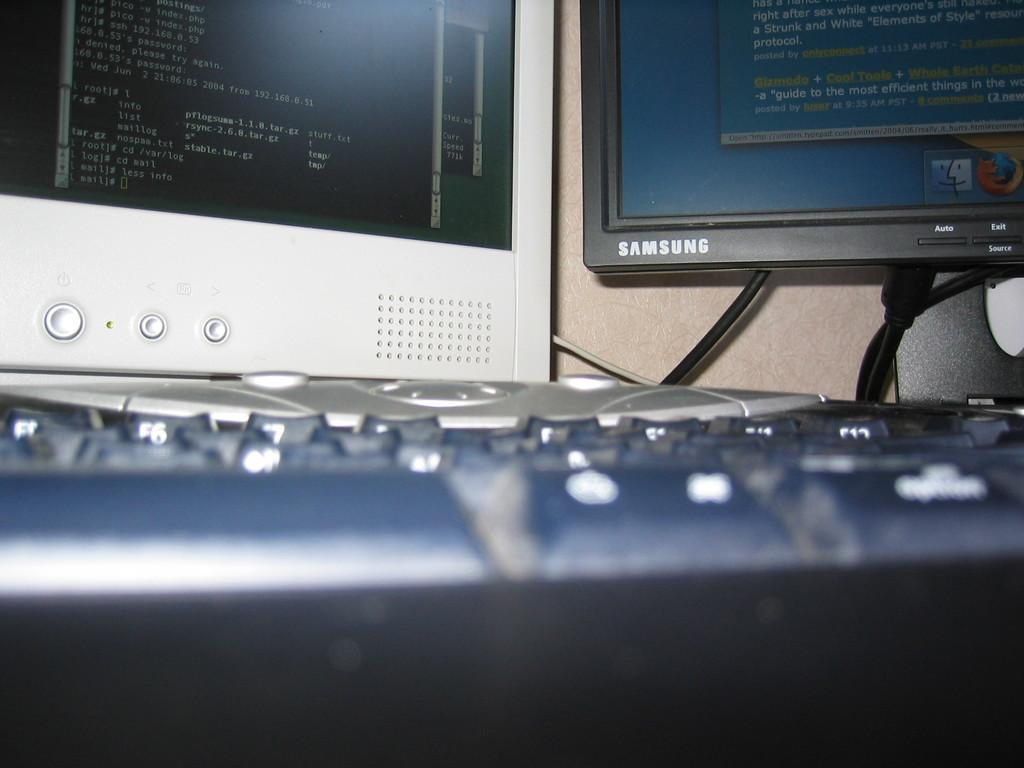Provide a one-sentence caption for the provided image. Two monitors, one of them samsung,  in front of a keyboard. 